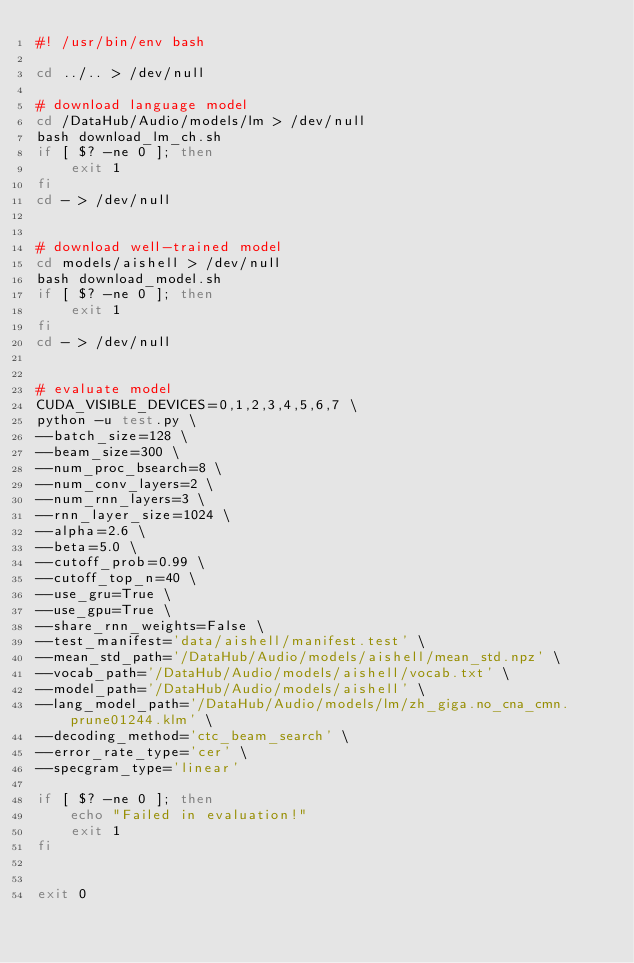Convert code to text. <code><loc_0><loc_0><loc_500><loc_500><_Bash_>#! /usr/bin/env bash

cd ../.. > /dev/null

# download language model
cd /DataHub/Audio/models/lm > /dev/null
bash download_lm_ch.sh
if [ $? -ne 0 ]; then
    exit 1
fi
cd - > /dev/null


# download well-trained model
cd models/aishell > /dev/null
bash download_model.sh
if [ $? -ne 0 ]; then
    exit 1
fi
cd - > /dev/null


# evaluate model
CUDA_VISIBLE_DEVICES=0,1,2,3,4,5,6,7 \
python -u test.py \
--batch_size=128 \
--beam_size=300 \
--num_proc_bsearch=8 \
--num_conv_layers=2 \
--num_rnn_layers=3 \
--rnn_layer_size=1024 \
--alpha=2.6 \
--beta=5.0 \
--cutoff_prob=0.99 \
--cutoff_top_n=40 \
--use_gru=True \
--use_gpu=True \
--share_rnn_weights=False \
--test_manifest='data/aishell/manifest.test' \
--mean_std_path='/DataHub/Audio/models/aishell/mean_std.npz' \
--vocab_path='/DataHub/Audio/models/aishell/vocab.txt' \
--model_path='/DataHub/Audio/models/aishell' \
--lang_model_path='/DataHub/Audio/models/lm/zh_giga.no_cna_cmn.prune01244.klm' \
--decoding_method='ctc_beam_search' \
--error_rate_type='cer' \
--specgram_type='linear'

if [ $? -ne 0 ]; then
    echo "Failed in evaluation!"
    exit 1
fi


exit 0
</code> 